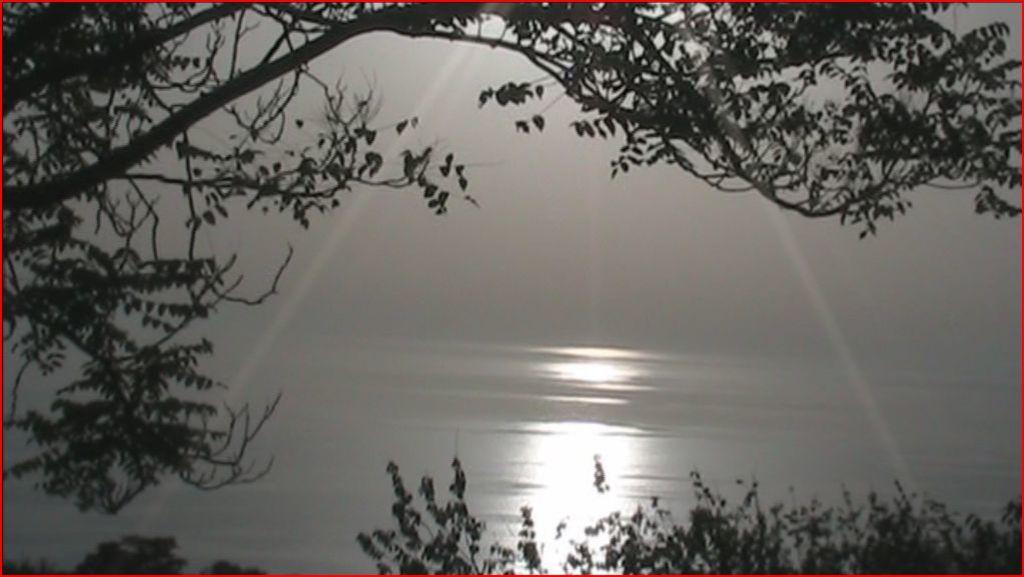What type of vegetation can be seen in the image? There are trees in the image. What natural element is visible besides the trees? There is water visible in the image. What can be seen in the background of the image? The sky is visible in the background of the image. Can you tell me how many geese are depicted in the image? There are no geese present in the image; it features trees and water. What type of metal object is shown interacting with the trees in the image? There is no metal object present in the image; it only features trees and water. 